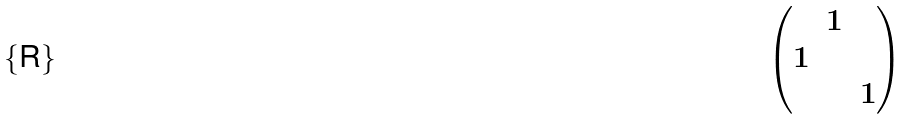<formula> <loc_0><loc_0><loc_500><loc_500>\begin{pmatrix} & 1 & \\ 1 & & \\ & & 1 \end{pmatrix}</formula> 